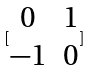Convert formula to latex. <formula><loc_0><loc_0><loc_500><loc_500>[ \begin{matrix} 0 & 1 \\ - 1 & 0 \end{matrix} ]</formula> 